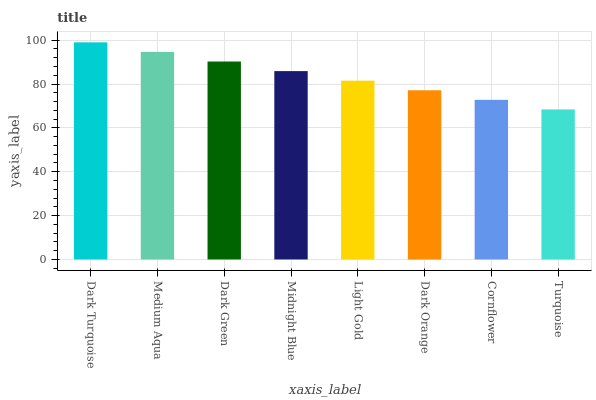Is Medium Aqua the minimum?
Answer yes or no. No. Is Medium Aqua the maximum?
Answer yes or no. No. Is Dark Turquoise greater than Medium Aqua?
Answer yes or no. Yes. Is Medium Aqua less than Dark Turquoise?
Answer yes or no. Yes. Is Medium Aqua greater than Dark Turquoise?
Answer yes or no. No. Is Dark Turquoise less than Medium Aqua?
Answer yes or no. No. Is Midnight Blue the high median?
Answer yes or no. Yes. Is Light Gold the low median?
Answer yes or no. Yes. Is Dark Green the high median?
Answer yes or no. No. Is Dark Orange the low median?
Answer yes or no. No. 